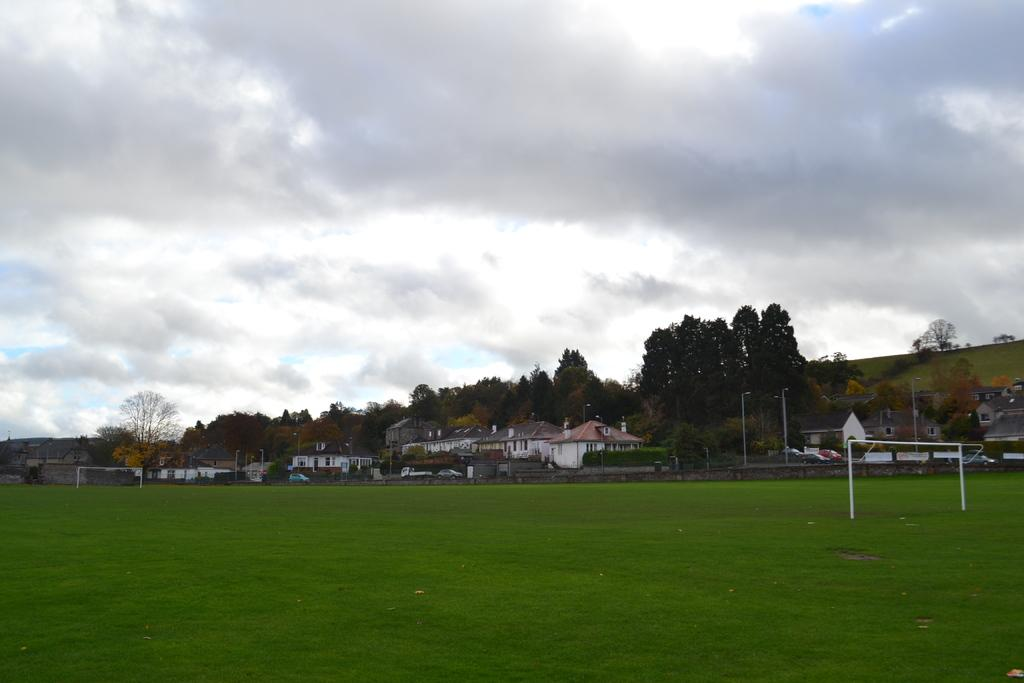What type of structures can be seen in the image? There are buildings in the image. What colors are the buildings? The buildings are in white and gray colors. What can be seen in the background of the image? There are trees in the background of the image. What color are the trees? The trees are green in color. What is visible above the buildings and trees? The sky is visible in the image. What colors can be seen in the sky? The sky is white and blue in color. How many cows can be seen grazing in the fields in the image? There are no cows or fields present in the image; it features buildings, trees, and a sky. What type of seed is used to grow the rice in the image? There is no rice or seed present in the image; it features buildings, trees, and a sky. 